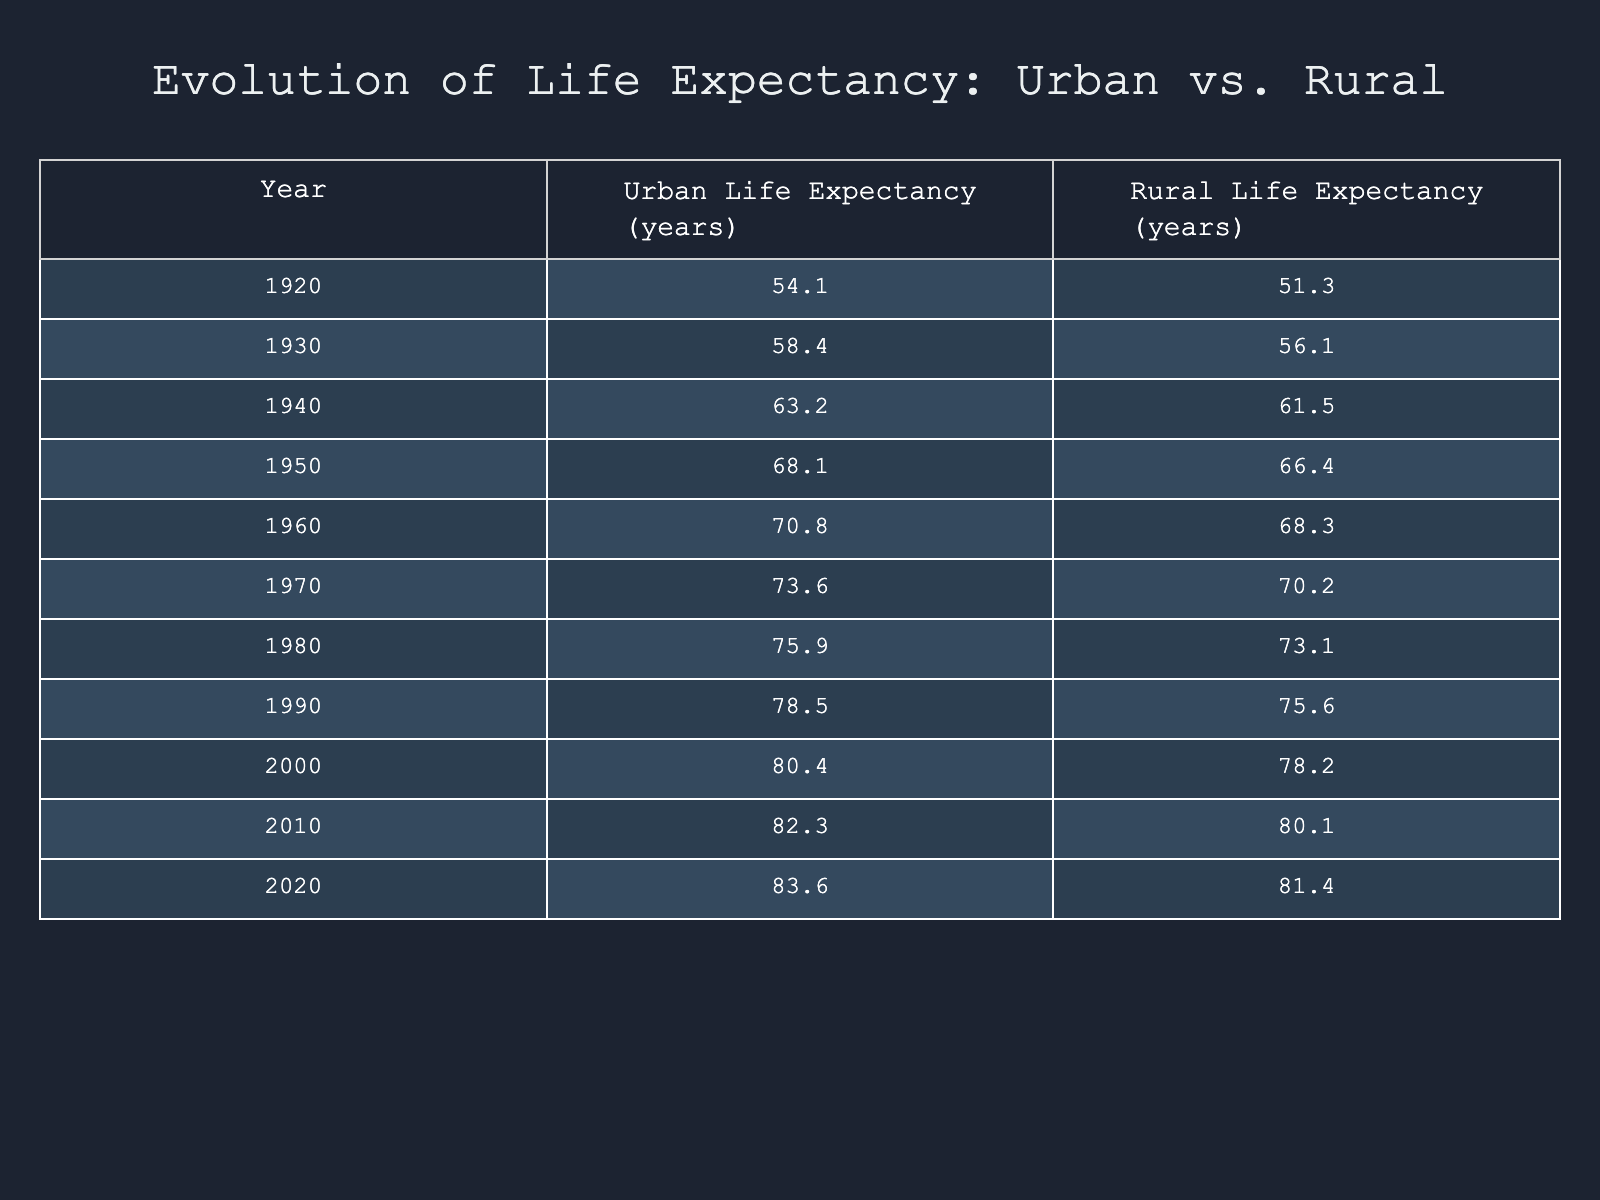What was the urban life expectancy in 1980? The table shows that in 1980, the urban life expectancy is directly listed as 75.9 years.
Answer: 75.9 What is the rural life expectancy in 1940? According to the table, the rural life expectancy for the year 1940 is 61.5 years.
Answer: 61.5 What was the difference in life expectancy between urban and rural areas in the year 2010? In 2010, the urban life expectancy was 82.3 years, while the rural life expectancy was 80.1 years. The difference is calculated as 82.3 - 80.1 = 2.2 years.
Answer: 2.2 years What is the average urban life expectancy over the last century (1920 to 2020)? To find the average, sum the urban life expectancies from 1920 to 2020: 54.1 + 58.4 + 63.2 + 68.1 + 70.8 + 73.6 + 75.9 + 78.5 + 80.4 + 82.3 + 83.6 =  829.5. There are 11 data points, so the average is 829.5 / 11 ≈ 75.4.
Answer: Approximately 75.4 Was there ever a year where rural life expectancy exceeded urban life expectancy? Referring to the table, the rural life expectancy never exceeds the urban life expectancy in any year recorded from 1920 to 2020; urban life expectancy was always higher.
Answer: No In which decade did urban life expectancy first rise above 70 years? From the table, urban life expectancy first exceeds 70 years in 1960, where it reached 70.8 years. Previous decades did not reach this mark.
Answer: 1960 